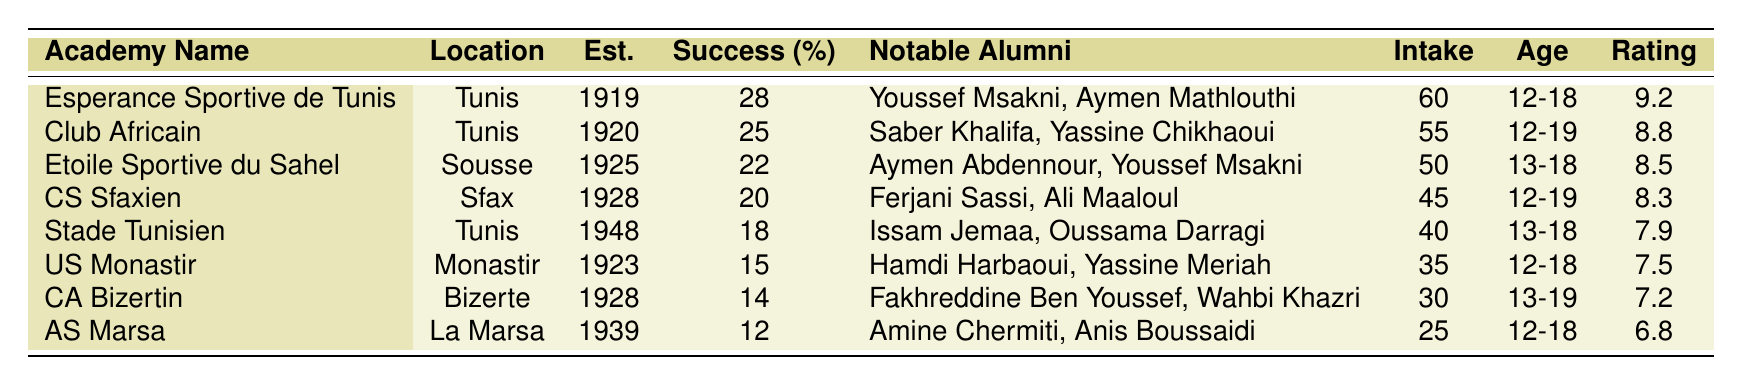What is the success rate of the Esperance Sportive de Tunis Academy? Referring to the table, the success rate for the Esperance Sportive de Tunis Academy is listed as 28%.
Answer: 28% Which academy has the highest facilities rating? Looking at the table, the highest facilities rating is associated with the Esperance Sportive de Tunis Academy, which has a rating of 9.2.
Answer: 9.2 How many notable alumni does the CS Sfaxien Academy have? The table indicates that the CS Sfaxien Academy has 45 notable alumni listed.
Answer: 45 What is the age range for students at the US Monastir Academy? According to the table, the age range for students at the US Monastir Academy is from 12 to 18 years old.
Answer: 12-18 Calculate the average success rate of all the academies. The success rates are 28, 25, 22, 20, 18, 15, 14, and 12. Adding them gives 28 + 25 + 22 + 20 + 18 + 15 + 14 + 12 = 154. There are 8 academies, so the average success rate is 154/8 = 19.25%.
Answer: 19.25% Which academy has the lowest success rate? The table shows that the AS Marsa Academy has the lowest success rate, which is 12%.
Answer: 12% Are there any academies established before 1920? By reviewing the table, it shows that the Esperance Sportive de Tunis Academy (1919) and Club Africain Academy (1920) were established before 1920, so the answer is yes.
Answer: Yes How many students does the Academy with the highest intake accept annually? The Esperance Sportive de Tunis Academy has the highest annual intake, allowing 60 students.
Answer: 60 Is the age range of the CA Bizertin Academy the same as the US Monastir Academy? The age range of the CA Bizertin Academy is 13-19, while the US Monastir Academy's age range is 12-18. Since these ranges are different, the answer is no.
Answer: No What notable alumni does the Etoile Sportive du Sahel Academy have? The table lists the notable alumni of the Etoile Sportive du Sahel Academy as Aymen Abdennour and Youssef Msakni.
Answer: Aymen Abdennour, Youssef Msakni How does the success rate of the Club Africain Academy compare to that of CS Sfaxien Academy? The Club Africain Academy has a success rate of 25%, whereas the CS Sfaxien Academy has a success rate of 20%. Since 25% is greater than 20%, Club Africain Academy has a higher rate.
Answer: Higher 